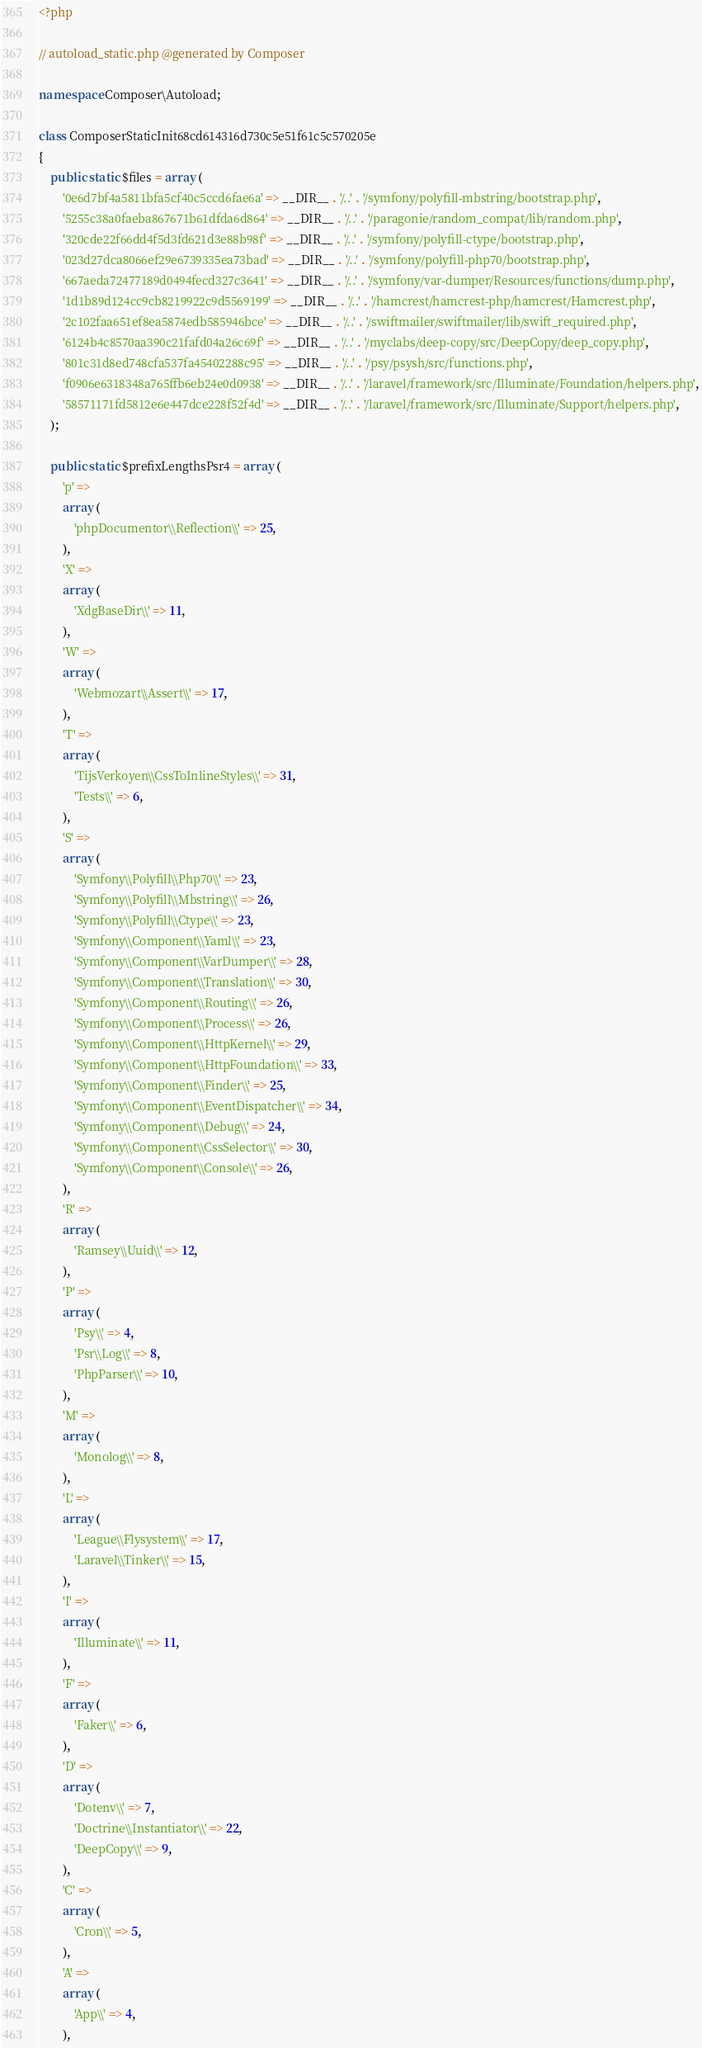Convert code to text. <code><loc_0><loc_0><loc_500><loc_500><_PHP_><?php

// autoload_static.php @generated by Composer

namespace Composer\Autoload;

class ComposerStaticInit68cd614316d730c5e51f61c5c570205e
{
    public static $files = array (
        '0e6d7bf4a5811bfa5cf40c5ccd6fae6a' => __DIR__ . '/..' . '/symfony/polyfill-mbstring/bootstrap.php',
        '5255c38a0faeba867671b61dfda6d864' => __DIR__ . '/..' . '/paragonie/random_compat/lib/random.php',
        '320cde22f66dd4f5d3fd621d3e88b98f' => __DIR__ . '/..' . '/symfony/polyfill-ctype/bootstrap.php',
        '023d27dca8066ef29e6739335ea73bad' => __DIR__ . '/..' . '/symfony/polyfill-php70/bootstrap.php',
        '667aeda72477189d0494fecd327c3641' => __DIR__ . '/..' . '/symfony/var-dumper/Resources/functions/dump.php',
        '1d1b89d124cc9cb8219922c9d5569199' => __DIR__ . '/..' . '/hamcrest/hamcrest-php/hamcrest/Hamcrest.php',
        '2c102faa651ef8ea5874edb585946bce' => __DIR__ . '/..' . '/swiftmailer/swiftmailer/lib/swift_required.php',
        '6124b4c8570aa390c21fafd04a26c69f' => __DIR__ . '/..' . '/myclabs/deep-copy/src/DeepCopy/deep_copy.php',
        '801c31d8ed748cfa537fa45402288c95' => __DIR__ . '/..' . '/psy/psysh/src/functions.php',
        'f0906e6318348a765ffb6eb24e0d0938' => __DIR__ . '/..' . '/laravel/framework/src/Illuminate/Foundation/helpers.php',
        '58571171fd5812e6e447dce228f52f4d' => __DIR__ . '/..' . '/laravel/framework/src/Illuminate/Support/helpers.php',
    );

    public static $prefixLengthsPsr4 = array (
        'p' => 
        array (
            'phpDocumentor\\Reflection\\' => 25,
        ),
        'X' => 
        array (
            'XdgBaseDir\\' => 11,
        ),
        'W' => 
        array (
            'Webmozart\\Assert\\' => 17,
        ),
        'T' => 
        array (
            'TijsVerkoyen\\CssToInlineStyles\\' => 31,
            'Tests\\' => 6,
        ),
        'S' => 
        array (
            'Symfony\\Polyfill\\Php70\\' => 23,
            'Symfony\\Polyfill\\Mbstring\\' => 26,
            'Symfony\\Polyfill\\Ctype\\' => 23,
            'Symfony\\Component\\Yaml\\' => 23,
            'Symfony\\Component\\VarDumper\\' => 28,
            'Symfony\\Component\\Translation\\' => 30,
            'Symfony\\Component\\Routing\\' => 26,
            'Symfony\\Component\\Process\\' => 26,
            'Symfony\\Component\\HttpKernel\\' => 29,
            'Symfony\\Component\\HttpFoundation\\' => 33,
            'Symfony\\Component\\Finder\\' => 25,
            'Symfony\\Component\\EventDispatcher\\' => 34,
            'Symfony\\Component\\Debug\\' => 24,
            'Symfony\\Component\\CssSelector\\' => 30,
            'Symfony\\Component\\Console\\' => 26,
        ),
        'R' => 
        array (
            'Ramsey\\Uuid\\' => 12,
        ),
        'P' => 
        array (
            'Psy\\' => 4,
            'Psr\\Log\\' => 8,
            'PhpParser\\' => 10,
        ),
        'M' => 
        array (
            'Monolog\\' => 8,
        ),
        'L' => 
        array (
            'League\\Flysystem\\' => 17,
            'Laravel\\Tinker\\' => 15,
        ),
        'I' => 
        array (
            'Illuminate\\' => 11,
        ),
        'F' => 
        array (
            'Faker\\' => 6,
        ),
        'D' => 
        array (
            'Dotenv\\' => 7,
            'Doctrine\\Instantiator\\' => 22,
            'DeepCopy\\' => 9,
        ),
        'C' => 
        array (
            'Cron\\' => 5,
        ),
        'A' => 
        array (
            'App\\' => 4,
        ),</code> 